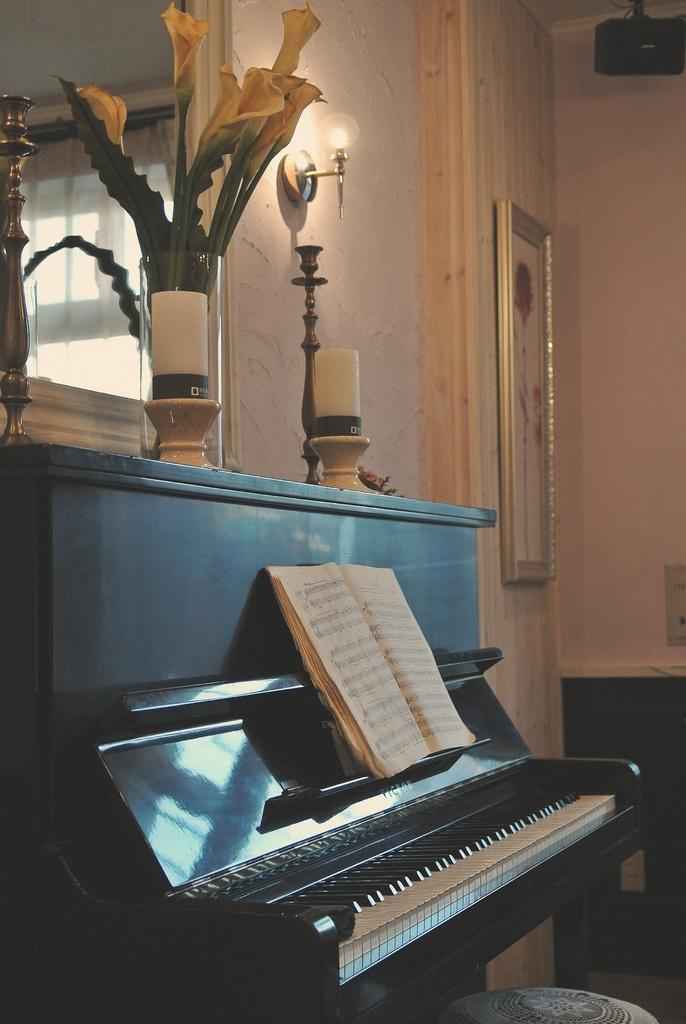What musical instrument is present in the image? There is a piano in the image. What object related to reading can be seen in the image? There is a book in the image. What can be seen in the background of the image? There is a wall and a frame in the background of the image. What type of plant is visible in the image? There is a plant in the image. What source of illumination is present in the image? There is a light in the image. What type of weather can be seen in the image? There is no weather depicted in the image; it is an indoor scene with a piano, book, wall, frame, plant, and light. What type of lamp is visible in the image? There is no lamp present in the image; it features a light source, but the type of light fixture is not specified. 